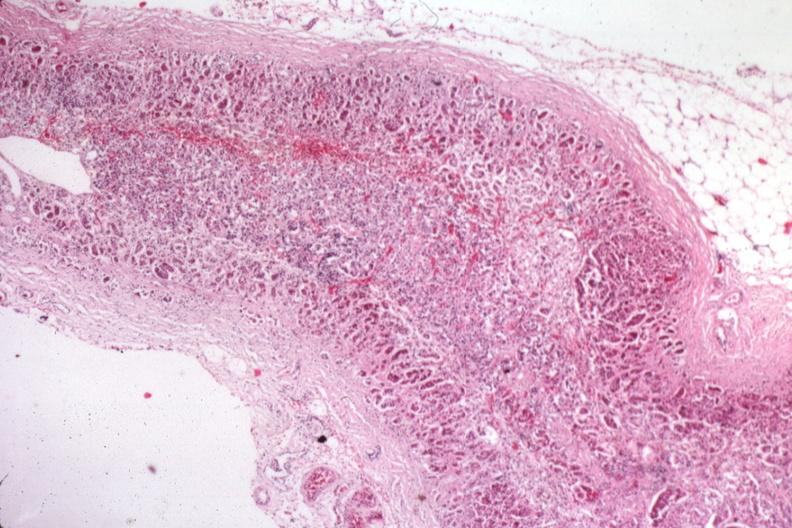what does this image show?
Answer the question using a single word or phrase. Atrophy secondary to corticoid therapy 